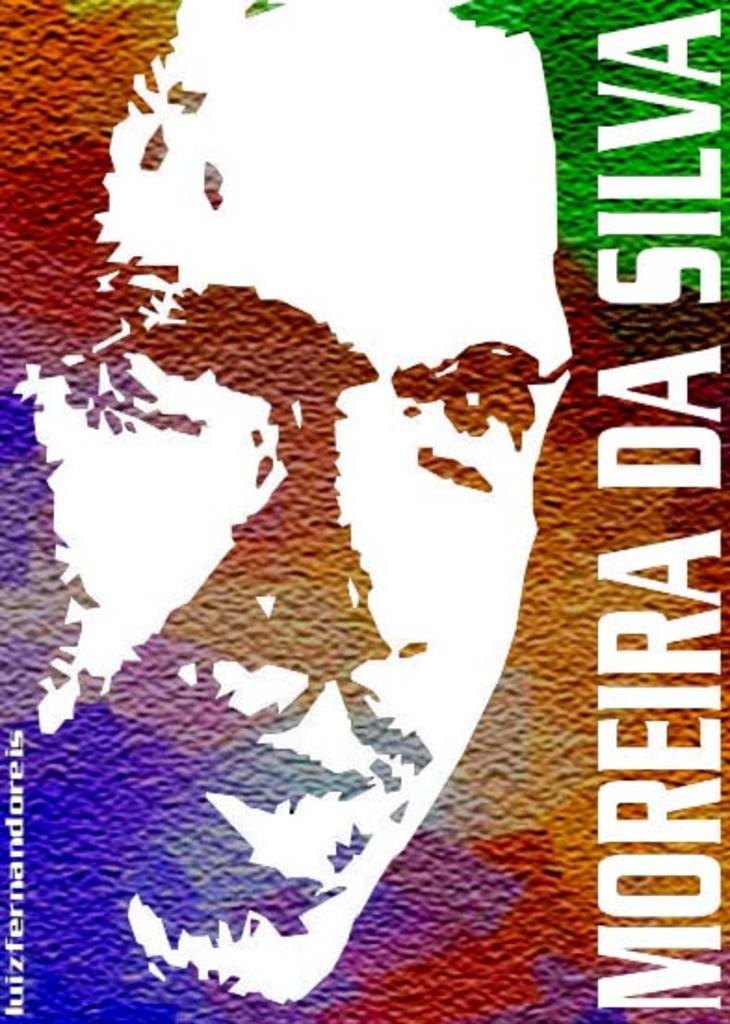Provide a one-sentence caption for the provided image. The artistic picture and name of a man is being displayed. 